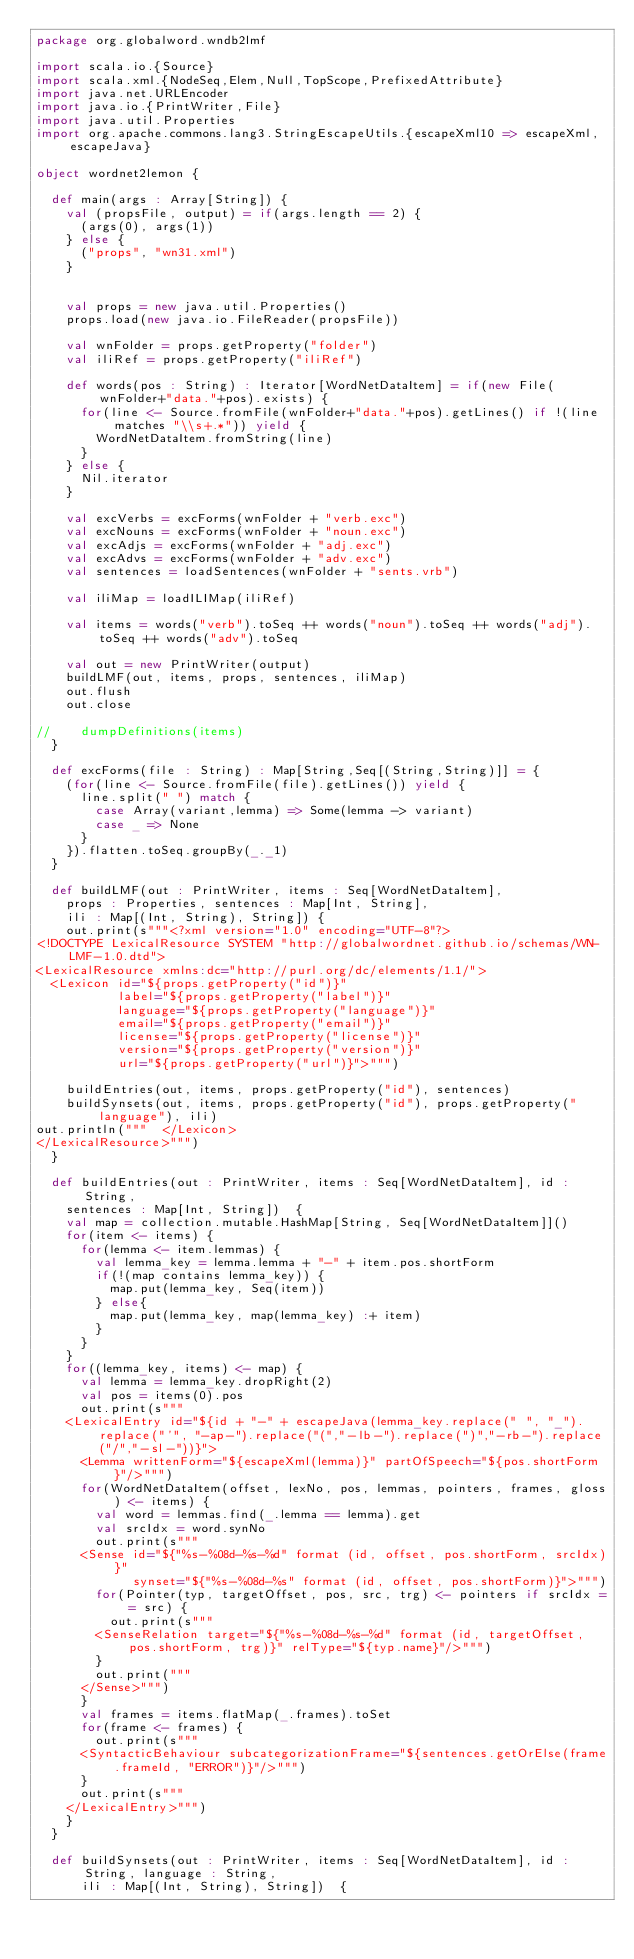<code> <loc_0><loc_0><loc_500><loc_500><_Scala_>package org.globalword.wndb2lmf

import scala.io.{Source}
import scala.xml.{NodeSeq,Elem,Null,TopScope,PrefixedAttribute}
import java.net.URLEncoder
import java.io.{PrintWriter,File}
import java.util.Properties
import org.apache.commons.lang3.StringEscapeUtils.{escapeXml10 => escapeXml, escapeJava}

object wordnet2lemon {

  def main(args : Array[String]) {
    val (propsFile, output) = if(args.length == 2) {
      (args(0), args(1))
    } else {
      ("props", "wn31.xml")
    }


    val props = new java.util.Properties()
    props.load(new java.io.FileReader(propsFile))

    val wnFolder = props.getProperty("folder")
    val iliRef = props.getProperty("iliRef")
    
    def words(pos : String) : Iterator[WordNetDataItem] = if(new File(wnFolder+"data."+pos).exists) {
      for(line <- Source.fromFile(wnFolder+"data."+pos).getLines() if !(line matches "\\s+.*")) yield {
        WordNetDataItem.fromString(line)
      }
    } else {
      Nil.iterator
    }
    
    val excVerbs = excForms(wnFolder + "verb.exc")
    val excNouns = excForms(wnFolder + "noun.exc")
    val excAdjs = excForms(wnFolder + "adj.exc")
    val excAdvs = excForms(wnFolder + "adv.exc")
    val sentences = loadSentences(wnFolder + "sents.vrb")
    
    val iliMap = loadILIMap(iliRef)
    
    val items = words("verb").toSeq ++ words("noun").toSeq ++ words("adj").toSeq ++ words("adv").toSeq
    
    val out = new PrintWriter(output)
    buildLMF(out, items, props, sentences, iliMap)
    out.flush
    out.close

//    dumpDefinitions(items)
  }
  
  def excForms(file : String) : Map[String,Seq[(String,String)]] = {
    (for(line <- Source.fromFile(file).getLines()) yield {
      line.split(" ") match {
        case Array(variant,lemma) => Some(lemma -> variant)
        case _ => None
      }
    }).flatten.toSeq.groupBy(_._1)
  }

  def buildLMF(out : PrintWriter, items : Seq[WordNetDataItem], 
    props : Properties, sentences : Map[Int, String],
    ili : Map[(Int, String), String]) {
    out.print(s"""<?xml version="1.0" encoding="UTF-8"?>
<!DOCTYPE LexicalResource SYSTEM "http://globalwordnet.github.io/schemas/WN-LMF-1.0.dtd">
<LexicalResource xmlns:dc="http://purl.org/dc/elements/1.1/">
  <Lexicon id="${props.getProperty("id")}" 
           label="${props.getProperty("label")}" 
           language="${props.getProperty("language")}"
           email="${props.getProperty("email")}"
           license="${props.getProperty("license")}"
           version="${props.getProperty("version")}"
           url="${props.getProperty("url")}">""")

    buildEntries(out, items, props.getProperty("id"), sentences)
    buildSynsets(out, items, props.getProperty("id"), props.getProperty("language"), ili)
out.println("""  </Lexicon>
</LexicalResource>""")
  }

  def buildEntries(out : PrintWriter, items : Seq[WordNetDataItem], id : String,
    sentences : Map[Int, String])  {
    val map = collection.mutable.HashMap[String, Seq[WordNetDataItem]]()
    for(item <- items) {
      for(lemma <- item.lemmas) {
        val lemma_key = lemma.lemma + "-" + item.pos.shortForm
        if(!(map contains lemma_key)) {
          map.put(lemma_key, Seq(item))
        } else{
          map.put(lemma_key, map(lemma_key) :+ item)
        }
      }
    }
    for((lemma_key, items) <- map) {
      val lemma = lemma_key.dropRight(2)
      val pos = items(0).pos 
      out.print(s"""
    <LexicalEntry id="${id + "-" + escapeJava(lemma_key.replace(" ", "_").replace("'", "-ap-").replace("(","-lb-").replace(")","-rb-").replace("/","-sl-"))}">
      <Lemma writtenForm="${escapeXml(lemma)}" partOfSpeech="${pos.shortForm}"/>""")
      for(WordNetDataItem(offset, lexNo, pos, lemmas, pointers, frames, gloss) <- items) {
        val word = lemmas.find(_.lemma == lemma).get
        val srcIdx = word.synNo
        out.print(s"""
      <Sense id="${"%s-%08d-%s-%d" format (id, offset, pos.shortForm, srcIdx)}"
             synset="${"%s-%08d-%s" format (id, offset, pos.shortForm)}">""")
        for(Pointer(typ, targetOffset, pos, src, trg) <- pointers if srcIdx == src) {
          out.print(s"""
        <SenseRelation target="${"%s-%08d-%s-%d" format (id, targetOffset, pos.shortForm, trg)}" relType="${typ.name}"/>""")
        }
        out.print("""
      </Sense>""")
      }
      val frames = items.flatMap(_.frames).toSet
      for(frame <- frames) {
        out.print(s"""
      <SyntacticBehaviour subcategorizationFrame="${sentences.getOrElse(frame.frameId, "ERROR")}"/>""") 
      }
      out.print(s"""
    </LexicalEntry>""")
    }
  }

  def buildSynsets(out : PrintWriter, items : Seq[WordNetDataItem], id : String, language : String,
      ili : Map[(Int, String), String])  {</code> 